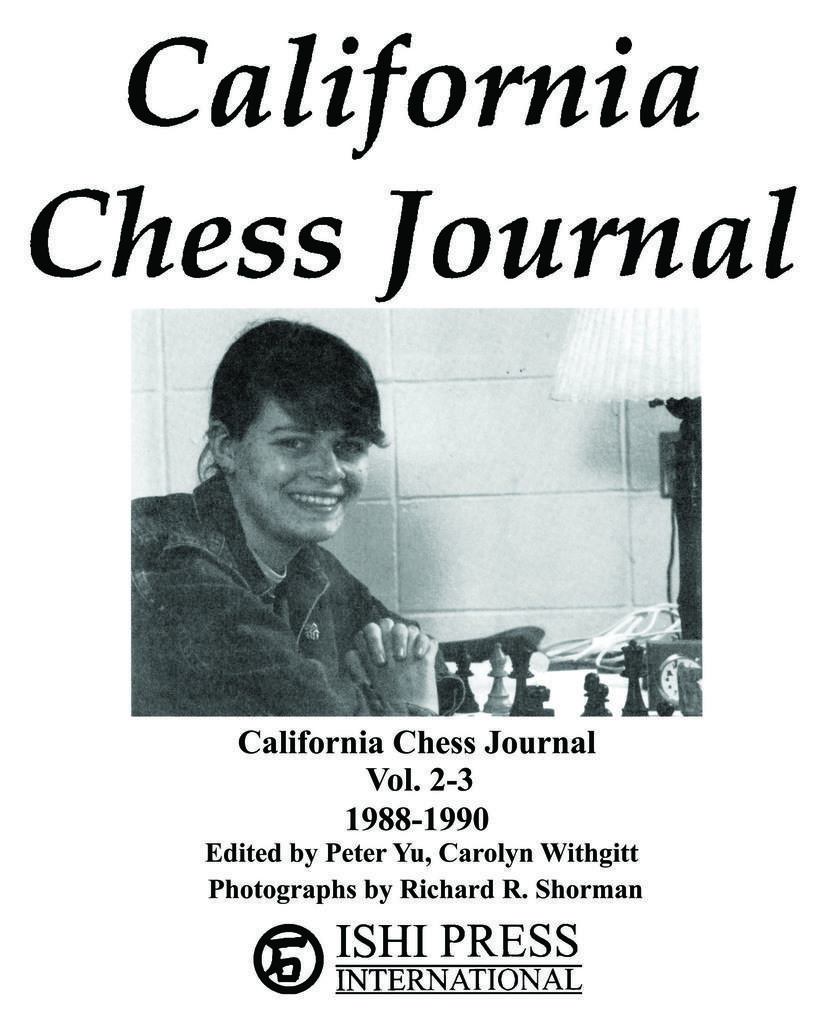Could you give a brief overview of what you see in this image? It is a poster. In the image we can see a woman is sitting and smiling and there is a table, on the table there are some chess pieces. Behind her there is a wall. 